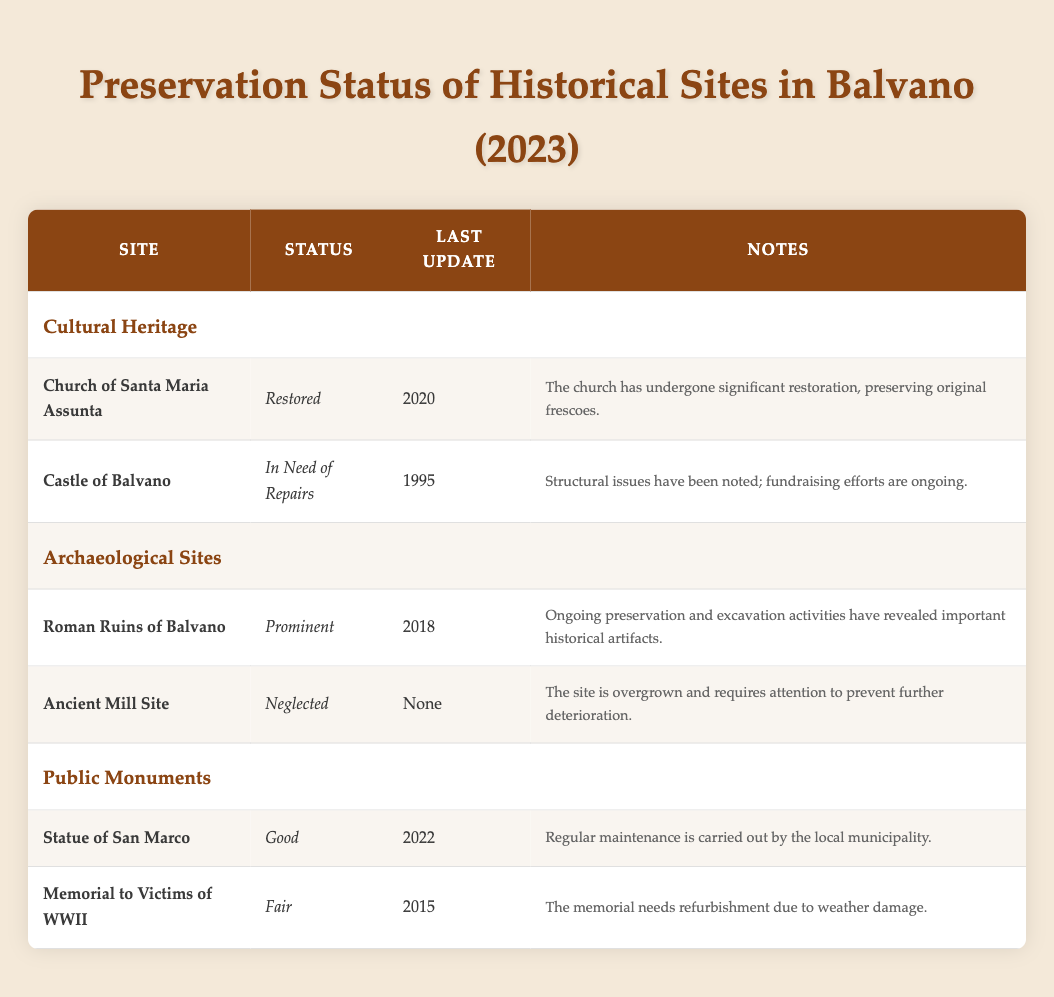What is the preservation status of the Church of Santa Maria Assunta? According to the table, the preservation status of the Church of Santa Maria Assunta is "Restored." This specific detail is directly mentioned in the preservation status column for this site.
Answer: Restored When was the last renovation of the Castle of Balvano? The last renovation date listed for the Castle of Balvano in the table is "1995." This information is found under the last renovation column for this specific site.
Answer: 1995 Are there any historical sites in Balvano that have a preservation status of "Neglected"? Yes, the table indicates that the Ancient Mill Site has a preservation status of "Neglected." This is clearly stated in the preservation status column for this site.
Answer: Yes Which site has undergone the most recent maintenance in 2022? The most recent maintenance activity in the year 2022 is associated with the Statue of San Marco, as noted in the last cleaning column for this site.
Answer: Statue of San Marco How many sites have a "Fair" or lower preservation status? To find this, we need to check the preservation status of all sites. The Castle of Balvano (In Need of Repairs), Ancient Mill Site (Neglected), and Memorial to Victims of WWII (Fair) add up to three sites. Hence, the total count of sites with a "Fair" or lower preservation status is 3.
Answer: 3 Which category has the most sites listed with a status of "Good"? The table shows that the category "Public Monuments" contains one site listed with a status of "Good," which is the Statue of San Marco. Various other categories contain sites but do not indicate any that have a status of "Good." Thus, the answer is "Public Monuments."
Answer: Public Monuments Was the last excavation of the Roman Ruins of Balvano conducted in 2023? No, the table specifies that the last excavation of the Roman Ruins of Balvano took place in 2018, which is clearly stated under the last excavation column for this site.
Answer: No Which historical site requires the most urgent attention based on the preservation status? The Ancient Mill Site has a preservation status of "Neglected," which indicates that it requires immediate attention compared to others. The urgency is further mentioned in the notes that the site is overgrown and needs to be cleared to prevent further deterioration.
Answer: Ancient Mill Site What is the difference in years since the last renovations for the Church of Santa Maria Assunta and the Castle of Balvano? The Church of Santa Maria Assunta was last renovated in 2020, while the Castle of Balvano's last renovation was in 1995. To find the difference, we calculate 2020 - 1995 = 25 years. Hence, the difference in years since the last renovations is 25 years.
Answer: 25 years 